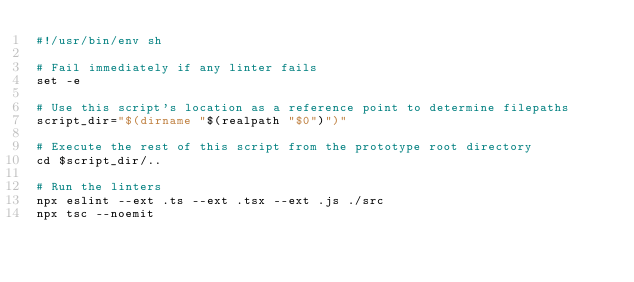Convert code to text. <code><loc_0><loc_0><loc_500><loc_500><_Bash_>#!/usr/bin/env sh

# Fail immediately if any linter fails
set -e

# Use this script's location as a reference point to determine filepaths
script_dir="$(dirname "$(realpath "$0")")"

# Execute the rest of this script from the prototype root directory
cd $script_dir/..

# Run the linters
npx eslint --ext .ts --ext .tsx --ext .js ./src
npx tsc --noemit
</code> 